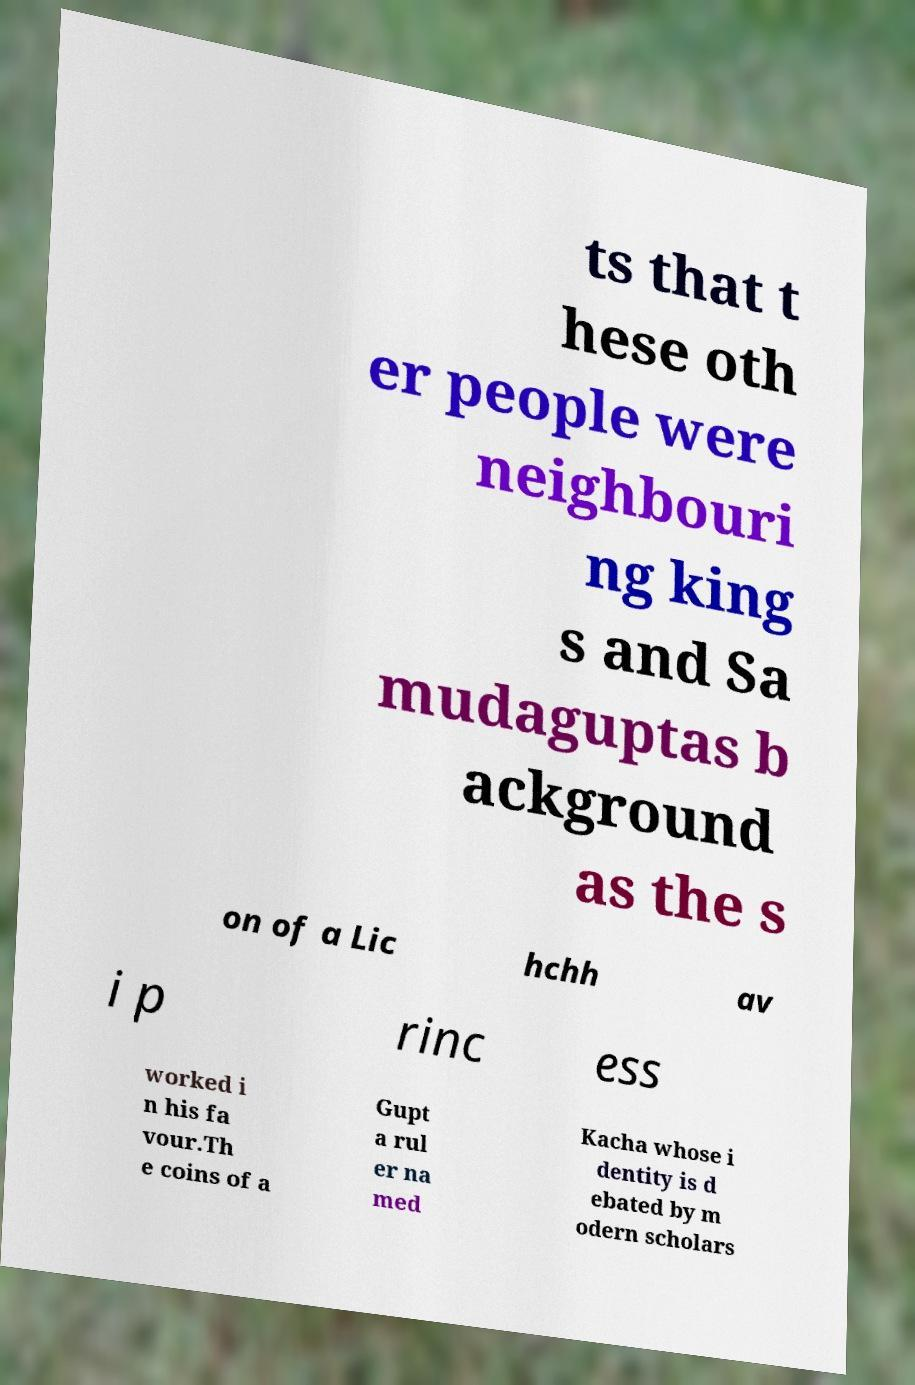Can you accurately transcribe the text from the provided image for me? ts that t hese oth er people were neighbouri ng king s and Sa mudaguptas b ackground as the s on of a Lic hchh av i p rinc ess worked i n his fa vour.Th e coins of a Gupt a rul er na med Kacha whose i dentity is d ebated by m odern scholars 